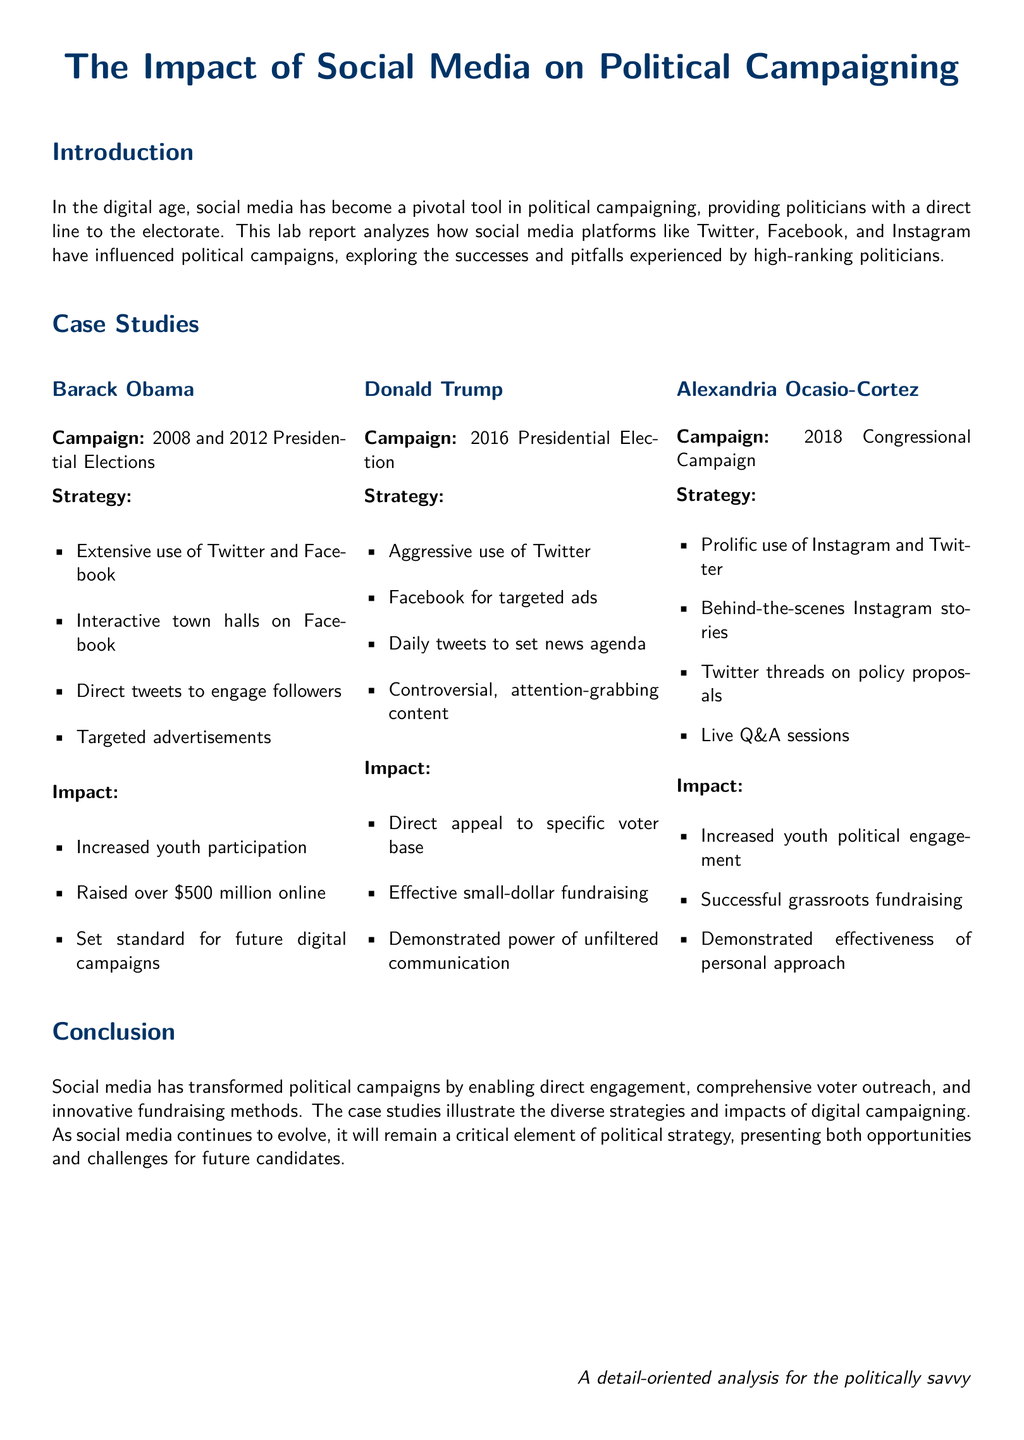What were the election years for Barack Obama's campaigns? The document specifies the years of Obama's campaigns as 2008 and 2012 Presidential Elections.
Answer: 2008 and 2012 How much money did Barack Obama's online campaign raise? The document states that Barack Obama's campaign raised over $500 million online.
Answer: over $500 million Which social media platform did Donald Trump use aggressively? The document indicates that Donald Trump made aggressive use of Twitter during his campaign.
Answer: Twitter What type of content did Donald Trump focus on in his campaign? The document mentions that Trump's campaign included controversial, attention-grabbing content.
Answer: controversial, attention-grabbing content What was a significant impact of Alexandria Ocasio-Cortez's social media use? The document notes that one significant impact was increased youth political engagement.
Answer: increased youth political engagement What strategy did Alexandria Ocasio-Cortez employ on Instagram? The document highlights her use of behind-the-scenes Instagram stories.
Answer: behind-the-scenes Instagram stories What is the overall conclusion of the report regarding social media's role in political campaigns? The conclusion indicates that social media has transformed political campaigns by enabling direct engagement and comprehensive voter outreach.
Answer: transformed political campaigns What type of fundraising method was notably effective for Donald Trump? The document specifies that his campaign was effective in small-dollar fundraising.
Answer: small-dollar fundraising What does the report suggest about the future of social media in political strategy? The document suggests that social media will remain a critical element of political strategy in the future.
Answer: a critical element of political strategy 